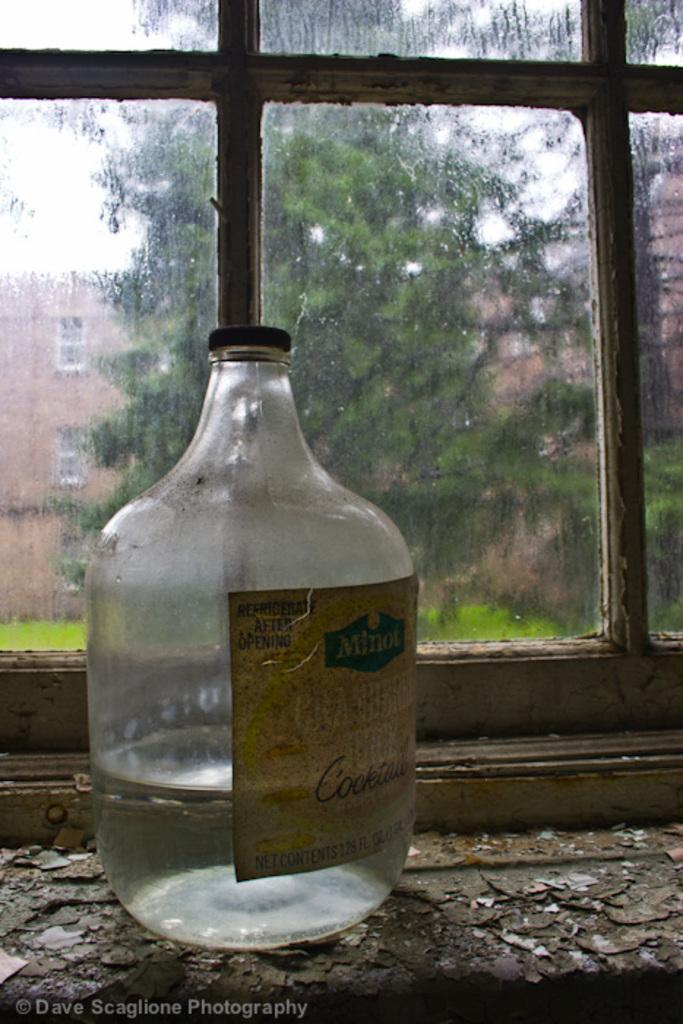<image>
Summarize the visual content of the image. A bottle made by Minot sits on a window sill during a rainy day. 